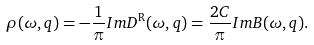Convert formula to latex. <formula><loc_0><loc_0><loc_500><loc_500>\rho ( \omega , q ) = - \frac { 1 } { \pi } I m D ^ { \text {R} } ( \omega , q ) = \frac { 2 C } { \pi } I m B ( \omega , q ) .</formula> 